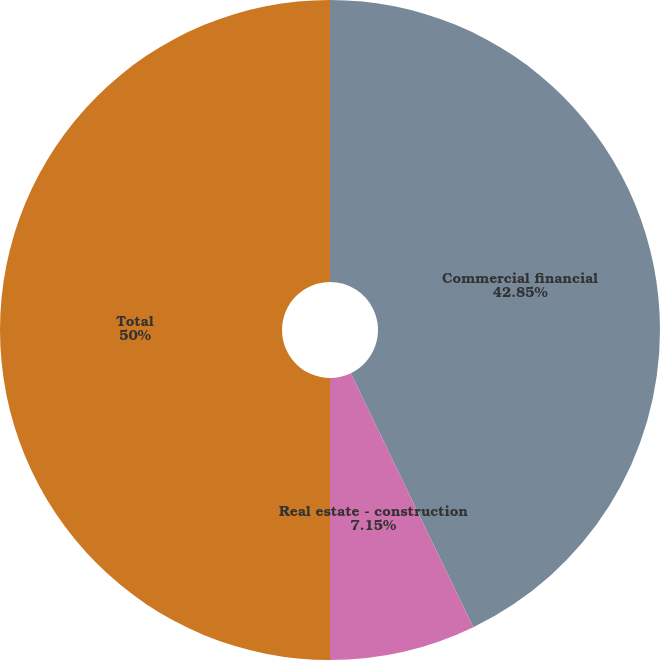Convert chart. <chart><loc_0><loc_0><loc_500><loc_500><pie_chart><fcel>Commercial financial<fcel>Real estate - construction<fcel>Total<nl><fcel>42.85%<fcel>7.15%<fcel>50.0%<nl></chart> 